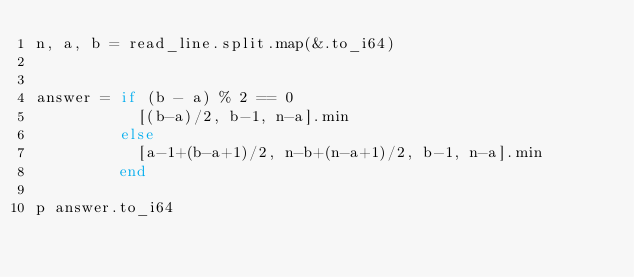Convert code to text. <code><loc_0><loc_0><loc_500><loc_500><_Crystal_>n, a, b = read_line.split.map(&.to_i64)


answer = if (b - a) % 2 == 0
           [(b-a)/2, b-1, n-a].min
         else
           [a-1+(b-a+1)/2, n-b+(n-a+1)/2, b-1, n-a].min
         end

p answer.to_i64
</code> 